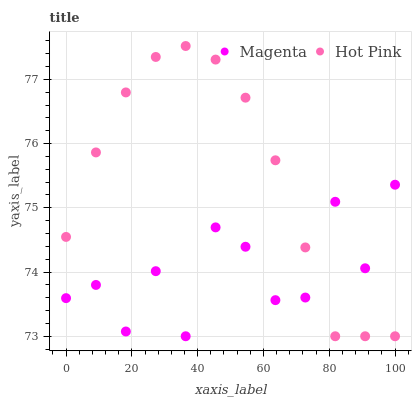Does Magenta have the minimum area under the curve?
Answer yes or no. Yes. Does Hot Pink have the maximum area under the curve?
Answer yes or no. Yes. Does Hot Pink have the minimum area under the curve?
Answer yes or no. No. Is Hot Pink the smoothest?
Answer yes or no. Yes. Is Magenta the roughest?
Answer yes or no. Yes. Is Hot Pink the roughest?
Answer yes or no. No. Does Magenta have the lowest value?
Answer yes or no. Yes. Does Hot Pink have the highest value?
Answer yes or no. Yes. Does Magenta intersect Hot Pink?
Answer yes or no. Yes. Is Magenta less than Hot Pink?
Answer yes or no. No. Is Magenta greater than Hot Pink?
Answer yes or no. No. 